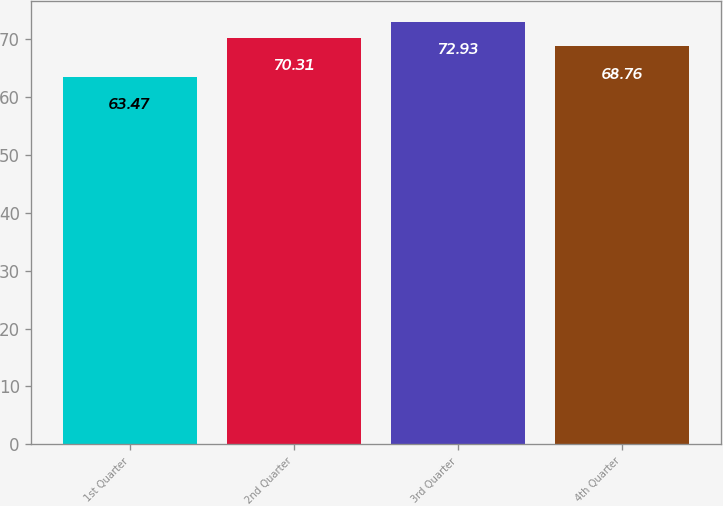Convert chart. <chart><loc_0><loc_0><loc_500><loc_500><bar_chart><fcel>1st Quarter<fcel>2nd Quarter<fcel>3rd Quarter<fcel>4th Quarter<nl><fcel>63.47<fcel>70.31<fcel>72.93<fcel>68.76<nl></chart> 